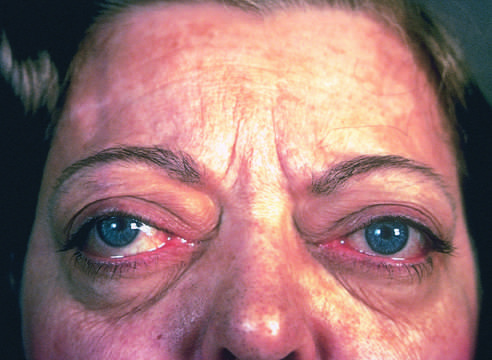s a wide-eyed, staring gaze, caused by overactivity of the sympathetic nervous system, one of the classic features of this disorder?
Answer the question using a single word or phrase. Yes 